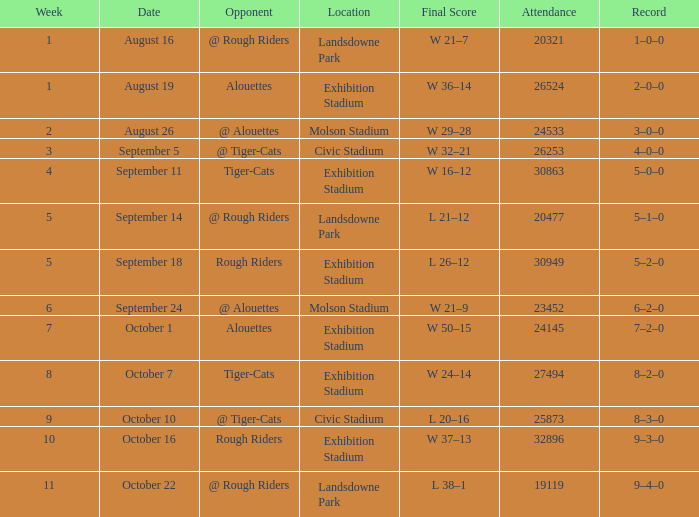What is the least value for week? 1.0. 